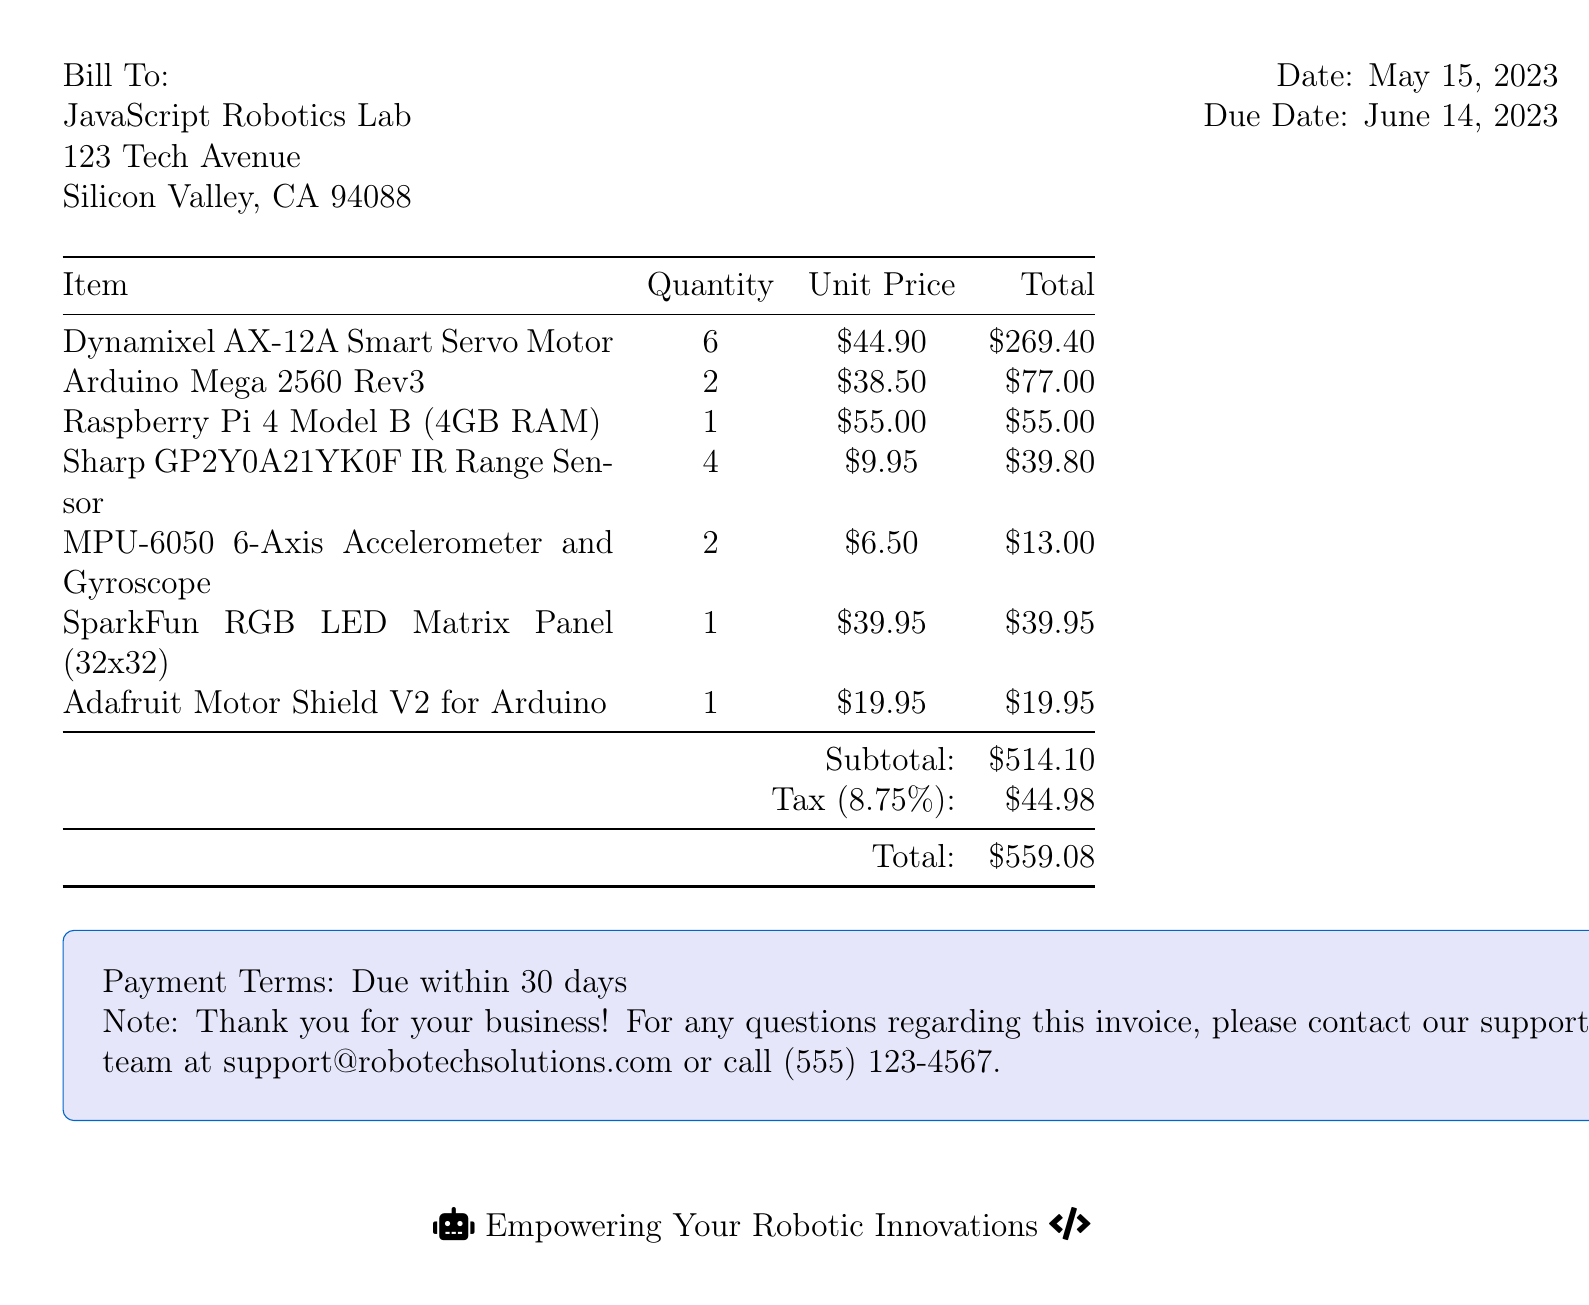What is the invoice number? The invoice number is listed at the top right of the document.
Answer: INV-2023-0542 Who is the bill recipient? The document indicates the name and address of the bill recipient.
Answer: JavaScript Robotics Lab What is the total amount due? The total amount due is calculated at the end of the invoice.
Answer: $559.08 How many Dynamixel AX-12A Smart Servo Motors were purchased? The quantity is provided next to the respective item in the invoice.
Answer: 6 What is the date of the invoice? The date is listed under the section with the recipient's address and payment dates.
Answer: May 15, 2023 What is the tax rate applied? The document specifies the tax as a percentage of the subtotal.
Answer: 8.75% What is included in the subtotal? The subtotal encompasses the total costs of items before tax.
Answer: $514.10 What payment terms are specified? The payment terms are stated under the terms section of the invoice.
Answer: Due within 30 days What is the contact method for invoice inquiries? The note at the end of the document specifies the contact method.
Answer: support@robotechsolutions.com 